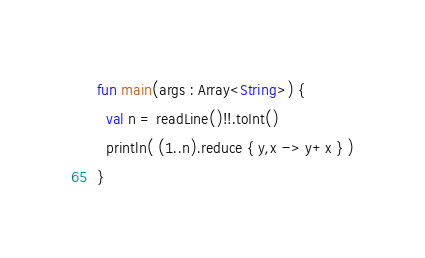Convert code to text. <code><loc_0><loc_0><loc_500><loc_500><_Kotlin_>fun main(args : Array<String>) {
  val n = readLine()!!.toInt()
  println( (1..n).reduce { y,x -> y+x } )
}
</code> 